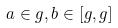Convert formula to latex. <formula><loc_0><loc_0><loc_500><loc_500>a \in g , b \in [ g , g ]</formula> 